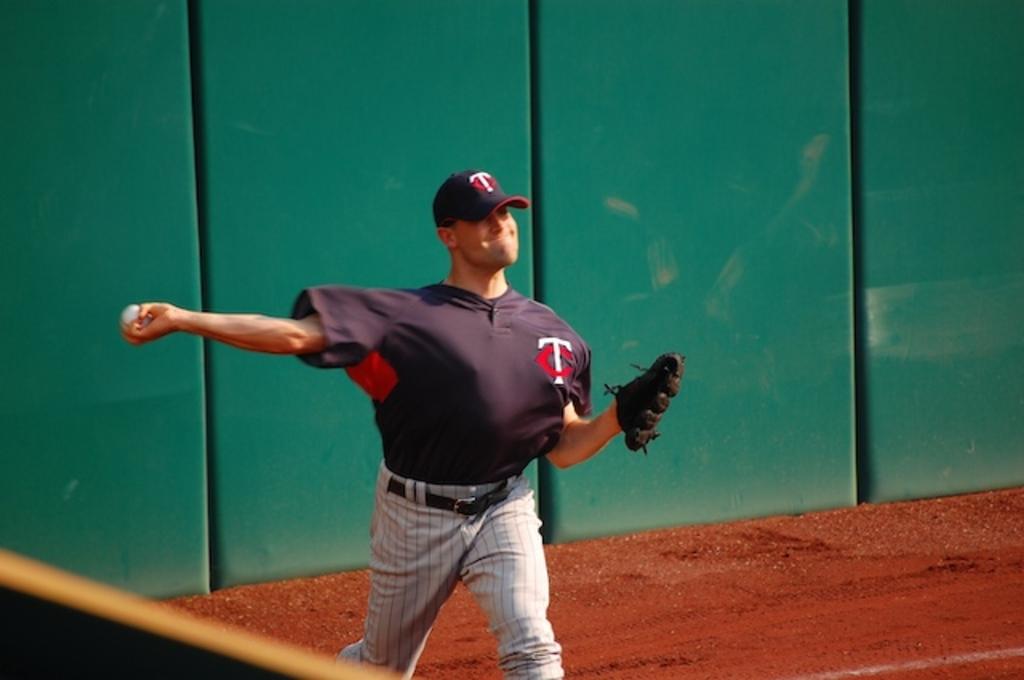What letters does the jersey say?
Your answer should be compact. Tc. 